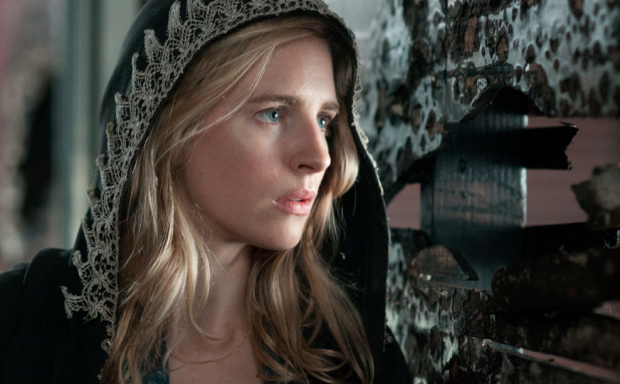Can you describe the setting and what feeling it evokes? The setting features a backdrop of a wall covered with peeling black and white posters, which contrasts markedly with the character's dark hooded cloak trimmed in white lace. This environment evokes a sense of decay and mystery, heightening the tension and suspense within the scene. The character's worried expression, paired with her contemplative gaze, suggests an intense moment ripe with anticipation and uncertainty. What do you think the character is anticipating? The character might be anticipating some grave news or a crucial encounter, perhaps involving a daring escape or the revelation of a hidden truth. Her worried yet determined expression indicates she is mentally preparing for a significant and possibly dangerous event. 